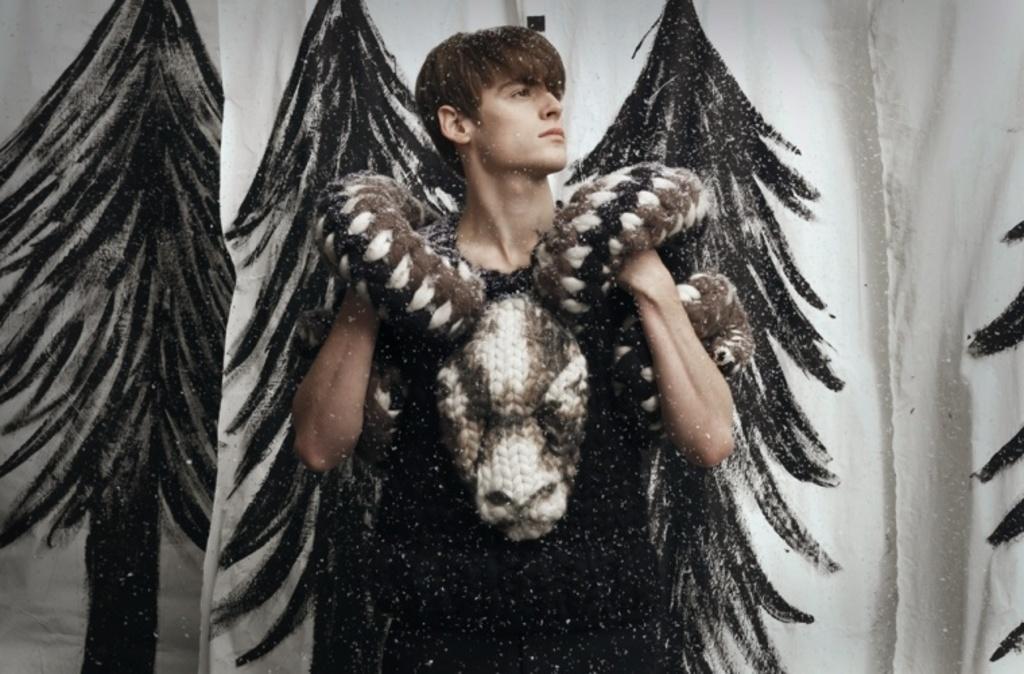Could you give a brief overview of what you see in this image? In this image there is a man standing. He is wearing a costume. Behind him there are clothes hanging. There is a print of trees on the cloth. 